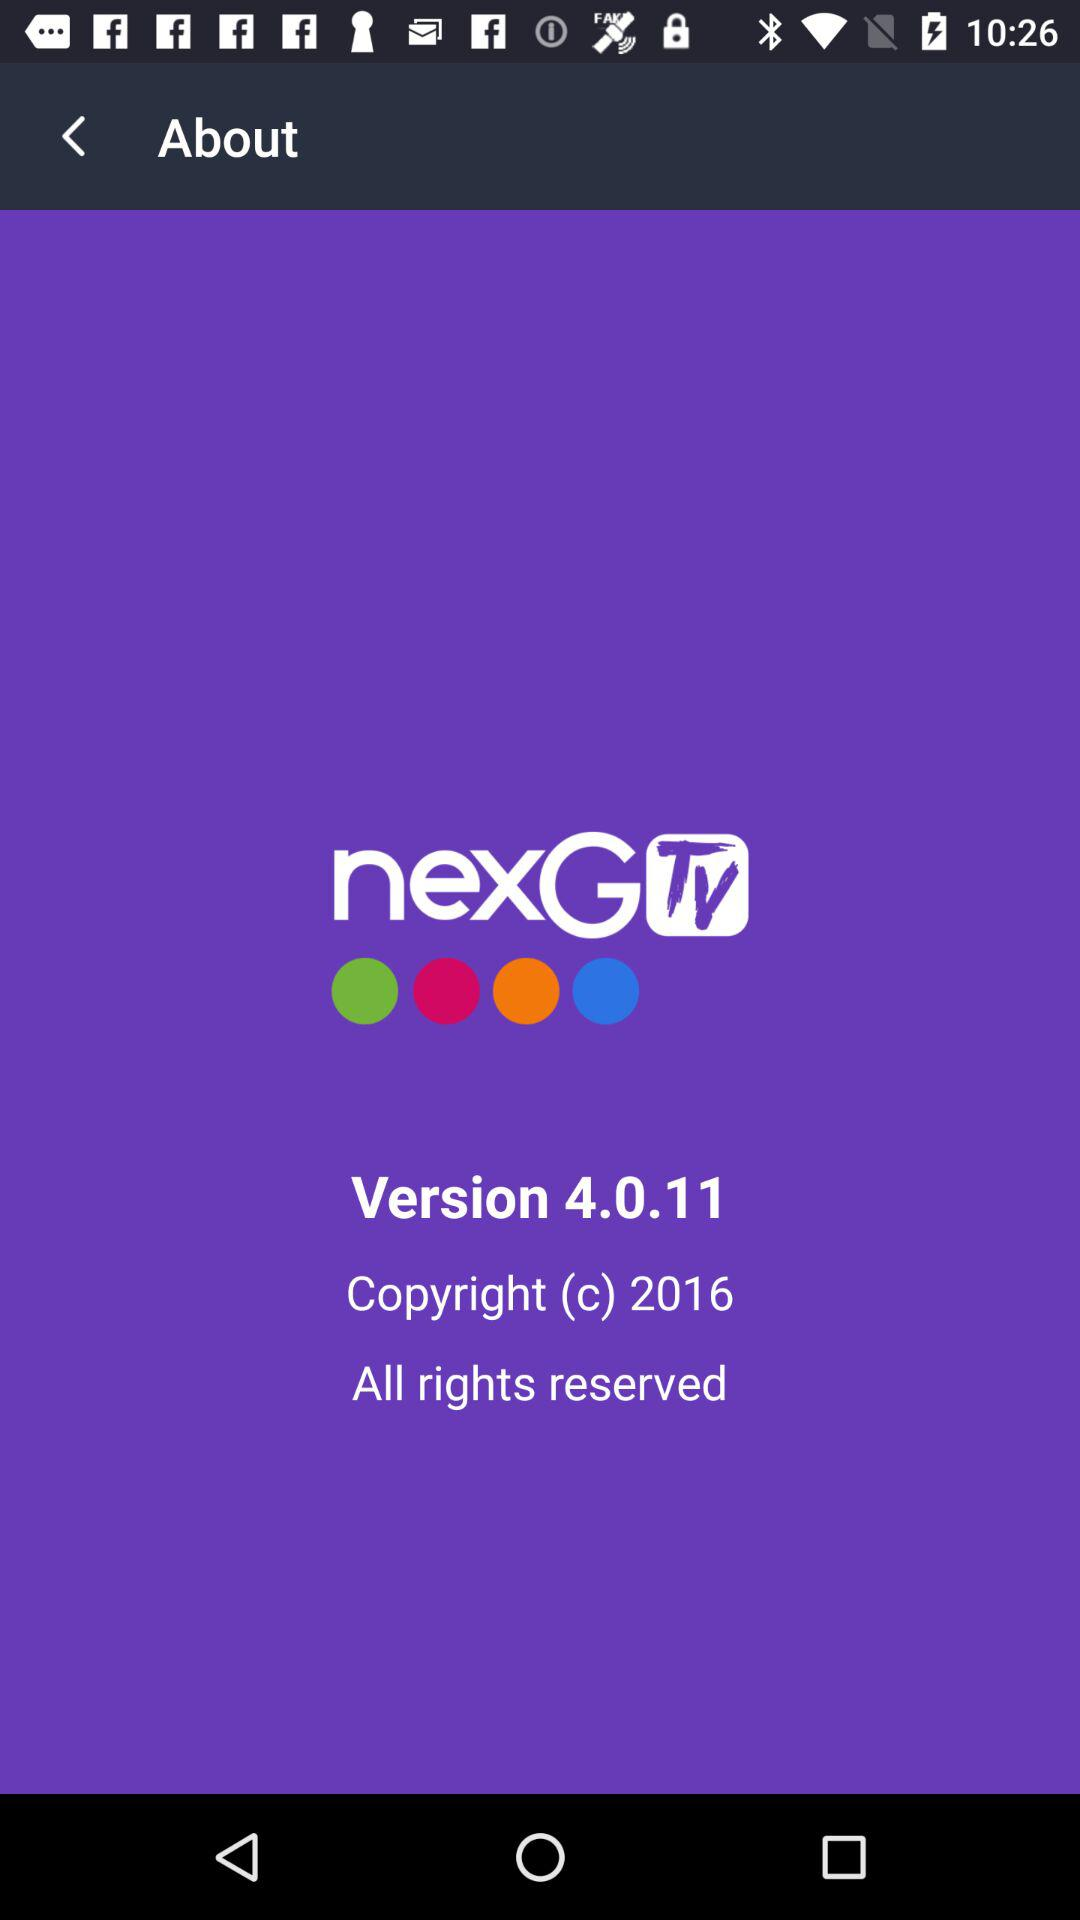What is the application name? The application name is "nexGTv". 